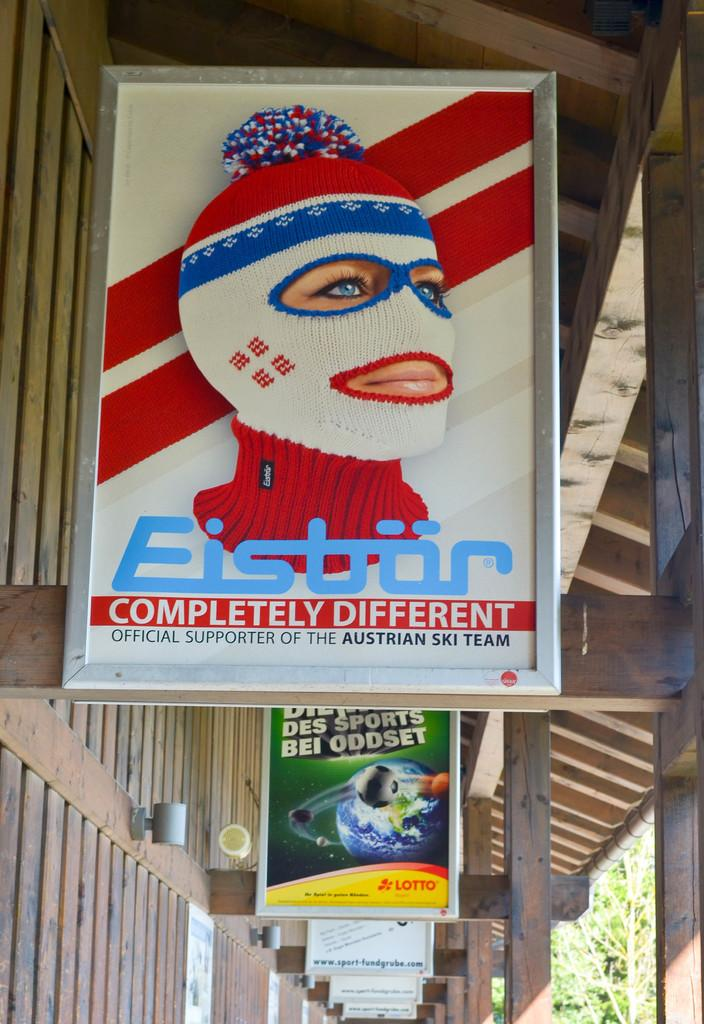Provide a one-sentence caption for the provided image. Eistor is an official supporter of the Austrian ski team. 